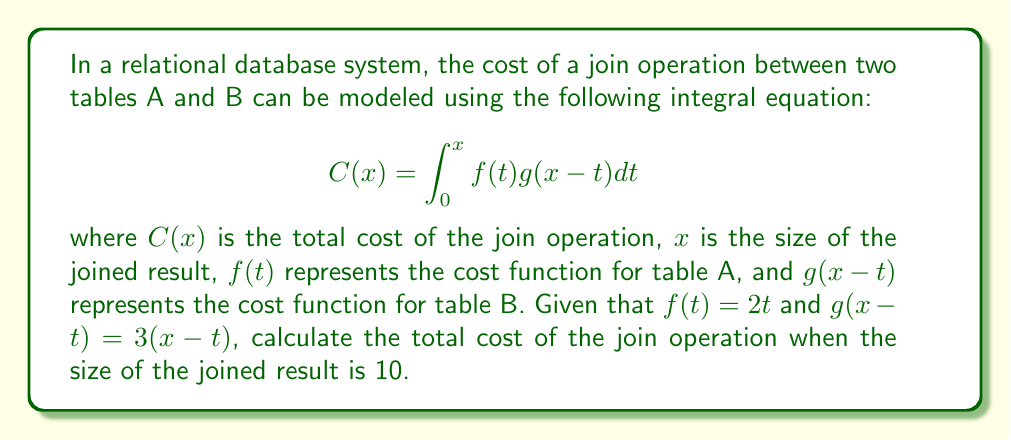Show me your answer to this math problem. To solve this problem, we'll follow these steps:

1) We're given the integral equation:
   $$C(x) = \int_0^x f(t)g(x-t)dt$$

2) We're also given that $f(t) = 2t$ and $g(x-t) = 3(x-t)$

3) Let's substitute these into our equation:
   $$C(x) = \int_0^x (2t)(3(x-t))dt$$

4) Simplify the integrand:
   $$C(x) = \int_0^x (6tx - 6t^2)dt$$

5) Now we can integrate:
   $$C(x) = [3t^2x - 2t^3]_0^x$$

6) Evaluate the definite integral:
   $$C(x) = (3x^3 - 2x^3) - (0)$$
   $$C(x) = x^3$$

7) We're asked to find the cost when $x = 10$:
   $$C(10) = 10^3 = 1000$$

Therefore, the total cost of the join operation when the size of the joined result is 10 is 1000.
Answer: 1000 